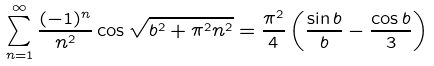<formula> <loc_0><loc_0><loc_500><loc_500>\sum _ { n = 1 } ^ { \infty } \frac { ( - 1 ) ^ { n } } { n ^ { 2 } } \cos \sqrt { b ^ { 2 } + \pi ^ { 2 } n ^ { 2 } } = \frac { \pi ^ { 2 } } 4 \left ( \frac { \sin b } b - \frac { \cos b } 3 \right )</formula> 